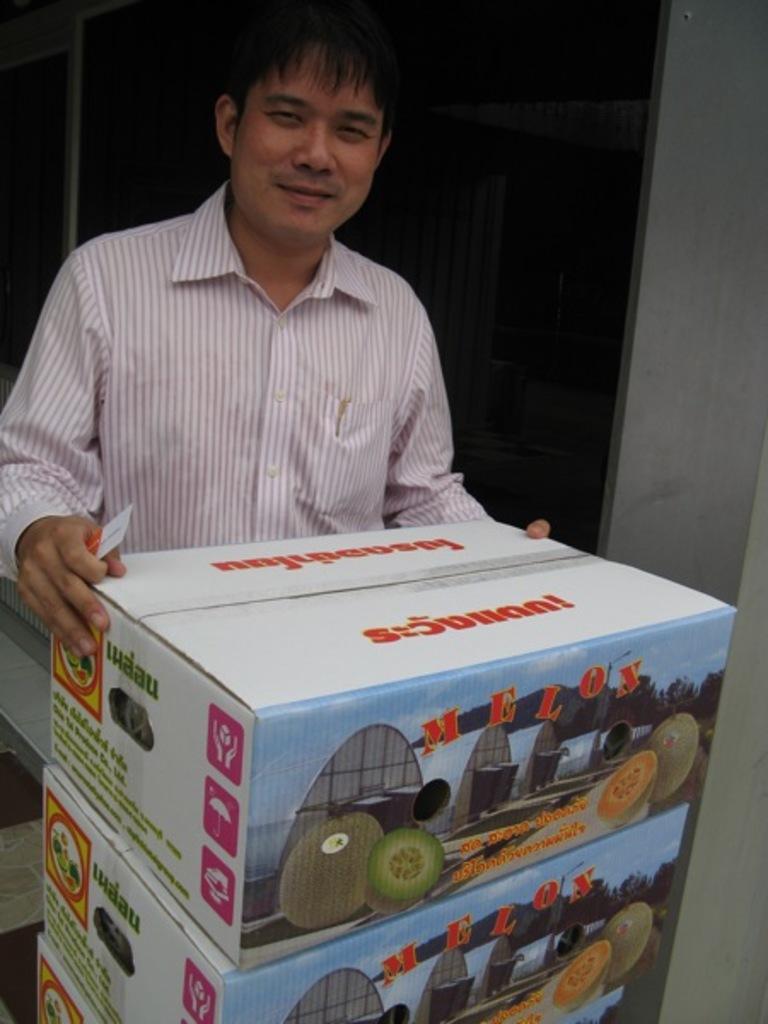What type of fruit is in the boxes?
Provide a short and direct response. Melon. 